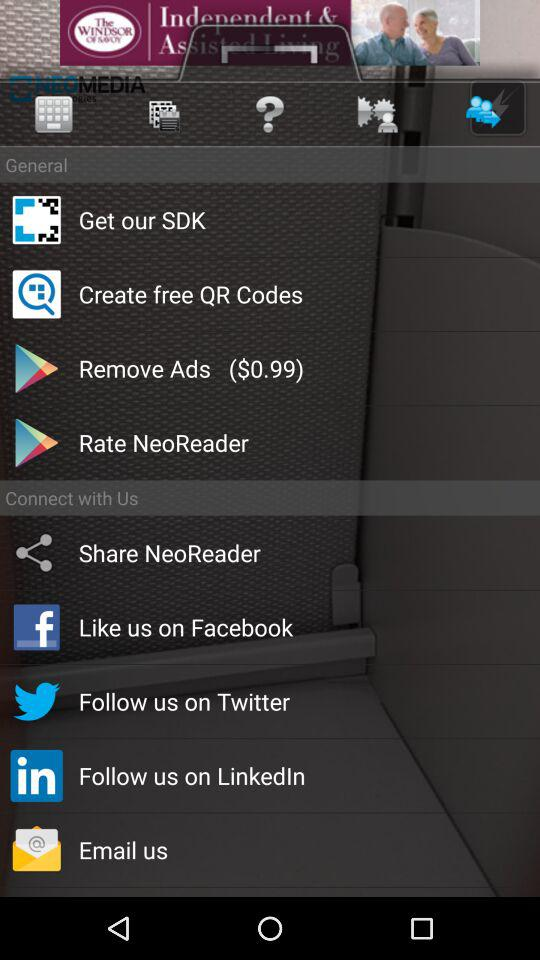What is the price shown here for removing the ads? The price shown here for removing the ads is $0.99. 